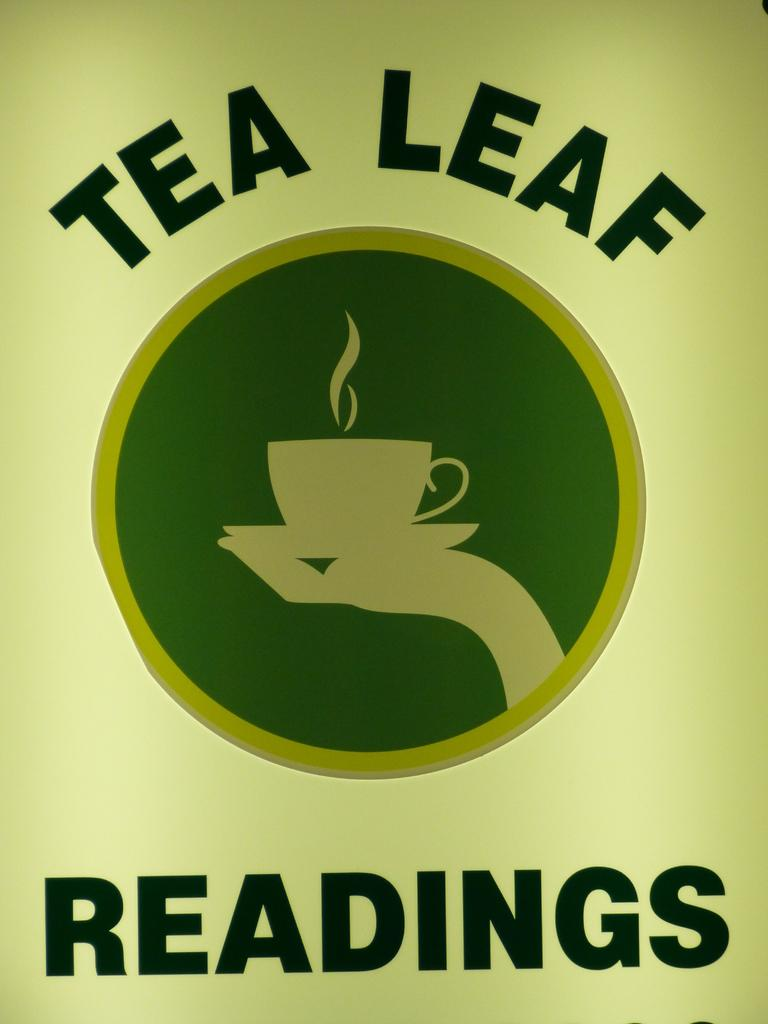<image>
Offer a succinct explanation of the picture presented. Green ad that says Tea Leaf Readings showing a logo of a cup in the middle. 